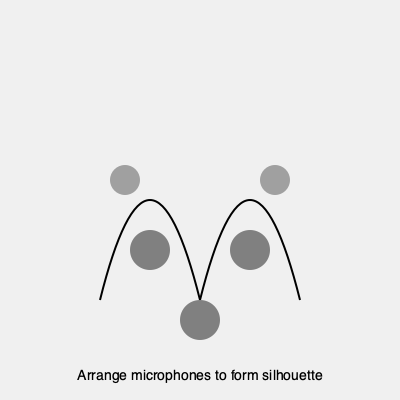Arrange the podcast microphones represented by circles to form the silhouette of Malala Yousafzai, a famous activist for female education. How many microphones are needed to create a recognizable outline of her face and signature headscarf? To create a recognizable silhouette of Malala Yousafzai using podcast microphones, we need to consider the key features of her appearance:

1. Face shape: Oval or round face, which can be represented by 2-3 microphones.
2. Headscarf: A distinctive feature, requiring 3-4 microphones to outline.
3. Chin and neck: 1-2 microphones to define the lower part of the face.
4. Shoulders: 2 microphones to suggest the upper body.

Step-by-step arrangement:
1. Place 2 microphones to form the top of the headscarf.
2. Use 2 microphones for the sides of the face, aligning with the headscarf.
3. Position 1 microphone for the chin.
4. Add 2 microphones for the shoulders.
5. Place 1 additional microphone to refine the curve of the headscarf if needed.

In total, a minimum of 7 microphones and a maximum of 8 microphones would be sufficient to create a recognizable silhouette of Malala Yousafzai, capturing her face shape and iconic headscarf.
Answer: 7-8 microphones 